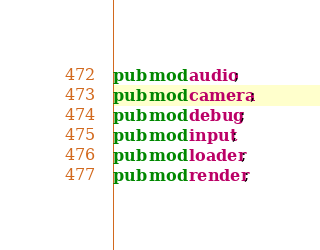Convert code to text. <code><loc_0><loc_0><loc_500><loc_500><_Rust_>pub mod audio;
pub mod camera;
pub mod debug;
pub mod input;
pub mod loader;
pub mod render;
</code> 